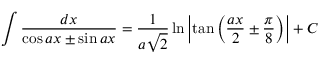Convert formula to latex. <formula><loc_0><loc_0><loc_500><loc_500>\int { \frac { d x } { \cos a x \pm \sin a x } } = { \frac { 1 } { a { \sqrt { 2 } } } } \ln \left | \tan \left ( { \frac { a x } { 2 } } \pm { \frac { \pi } { 8 } } \right ) \right | + C</formula> 